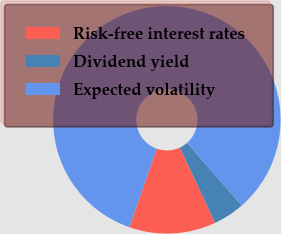Convert chart. <chart><loc_0><loc_0><loc_500><loc_500><pie_chart><fcel>Risk-free interest rates<fcel>Dividend yield<fcel>Expected volatility<nl><fcel>12.34%<fcel>4.46%<fcel>83.2%<nl></chart> 